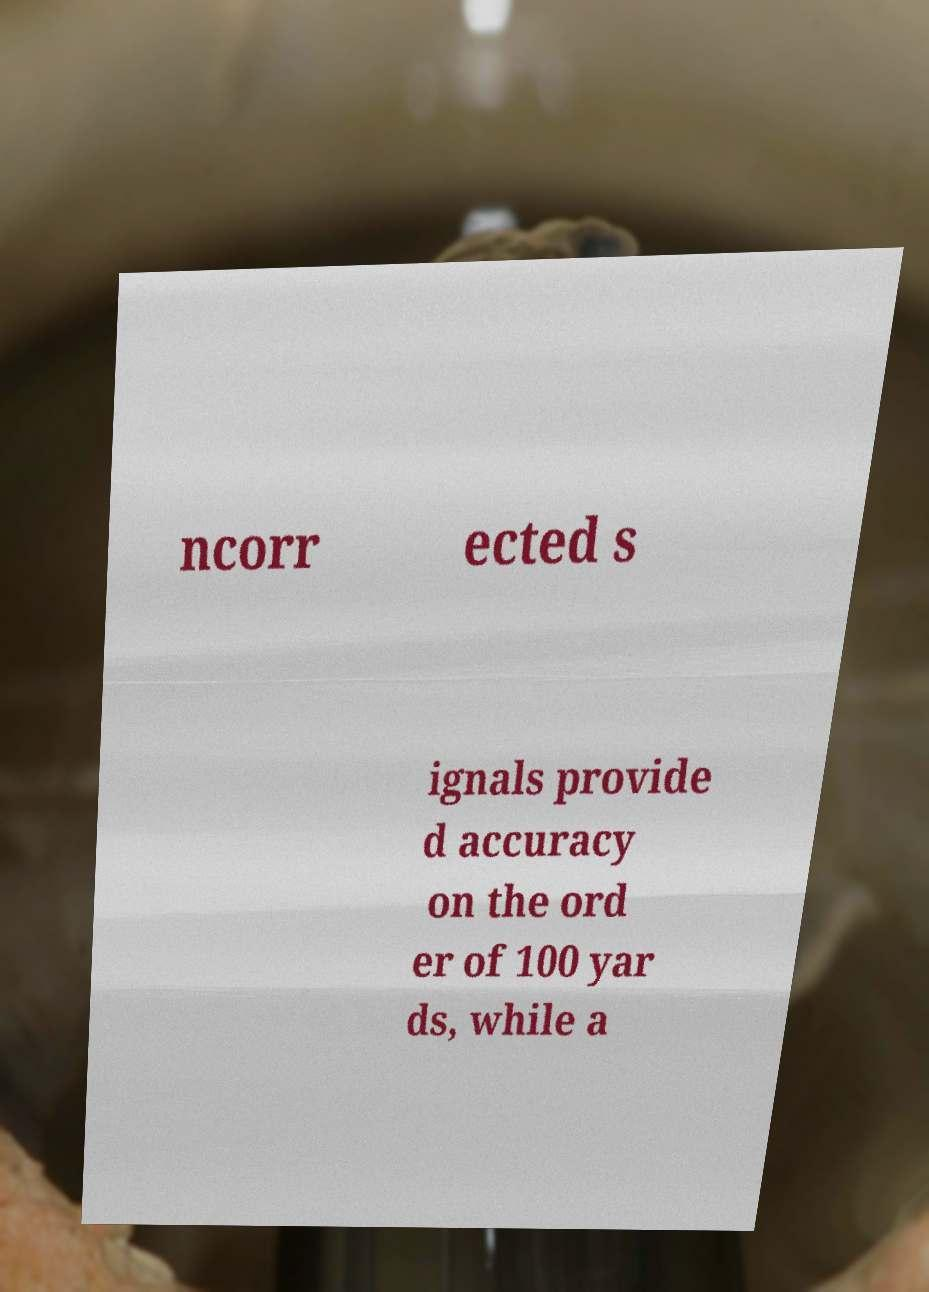Could you assist in decoding the text presented in this image and type it out clearly? ncorr ected s ignals provide d accuracy on the ord er of 100 yar ds, while a 